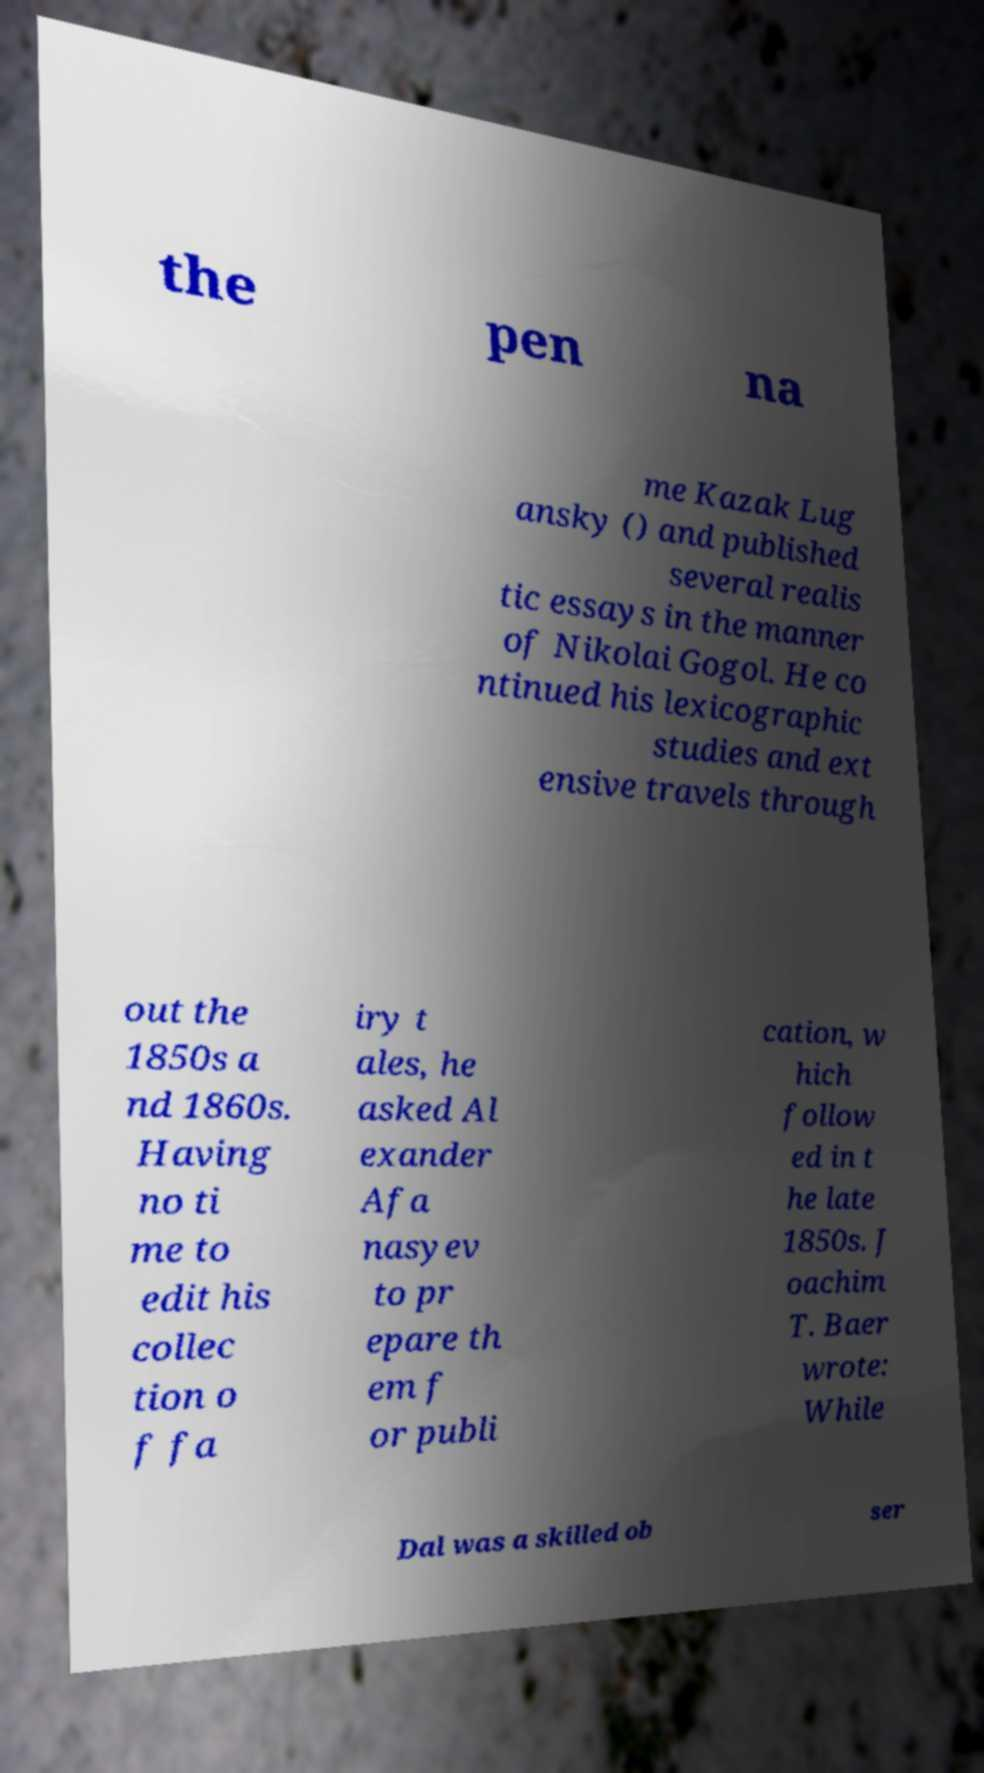There's text embedded in this image that I need extracted. Can you transcribe it verbatim? the pen na me Kazak Lug ansky () and published several realis tic essays in the manner of Nikolai Gogol. He co ntinued his lexicographic studies and ext ensive travels through out the 1850s a nd 1860s. Having no ti me to edit his collec tion o f fa iry t ales, he asked Al exander Afa nasyev to pr epare th em f or publi cation, w hich follow ed in t he late 1850s. J oachim T. Baer wrote: While Dal was a skilled ob ser 